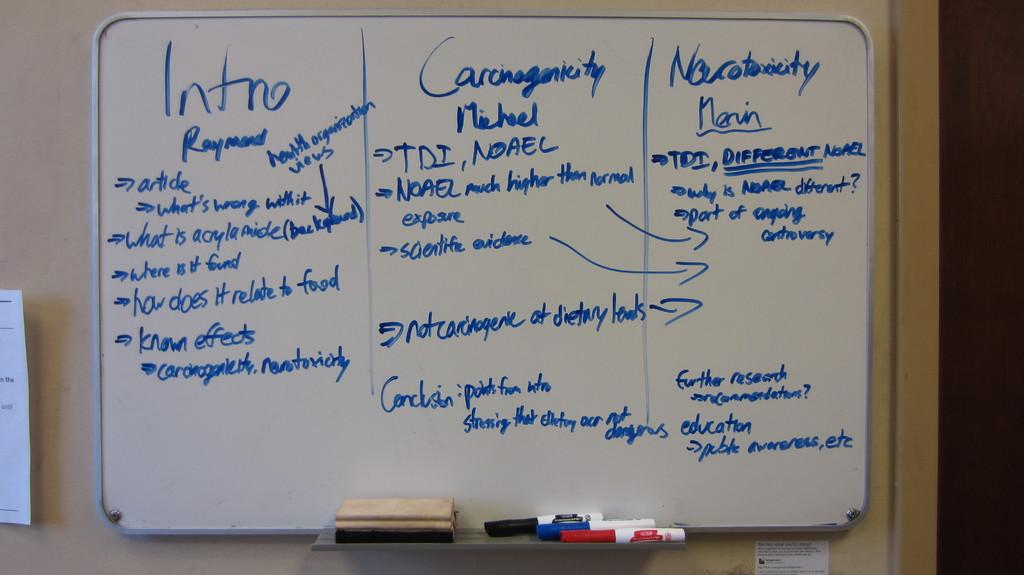<image>
Create a compact narrative representing the image presented. A marker board shows three sections intro, carcinogenicity, and narcotoxcity. 